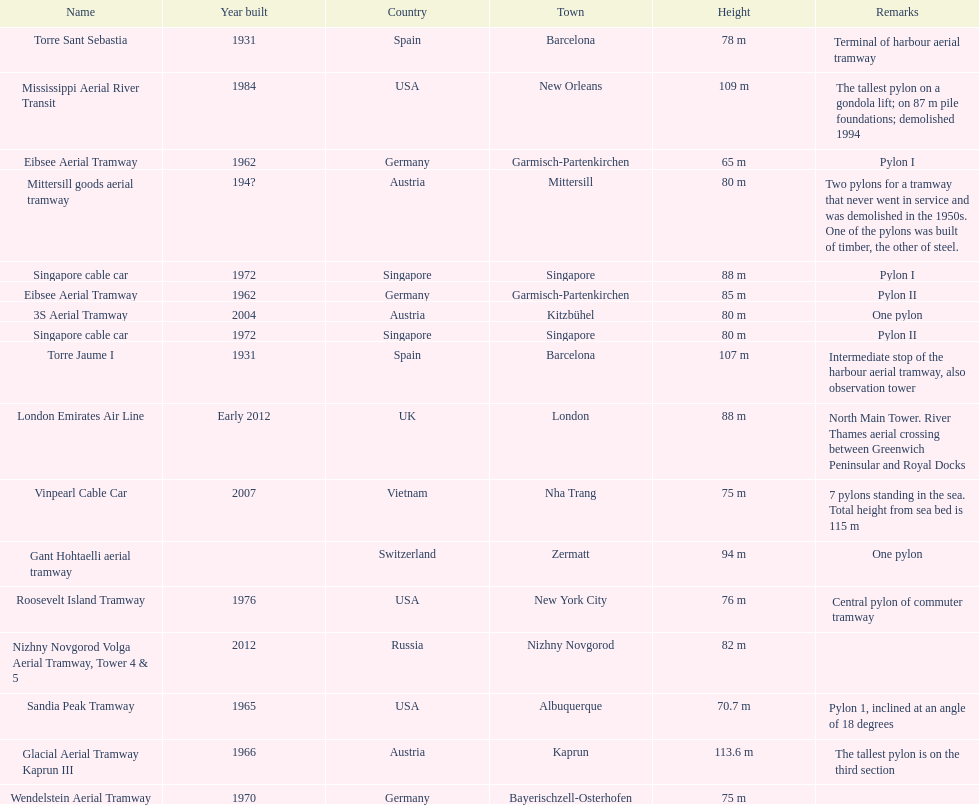What is the total number of tallest pylons in austria? 3. 